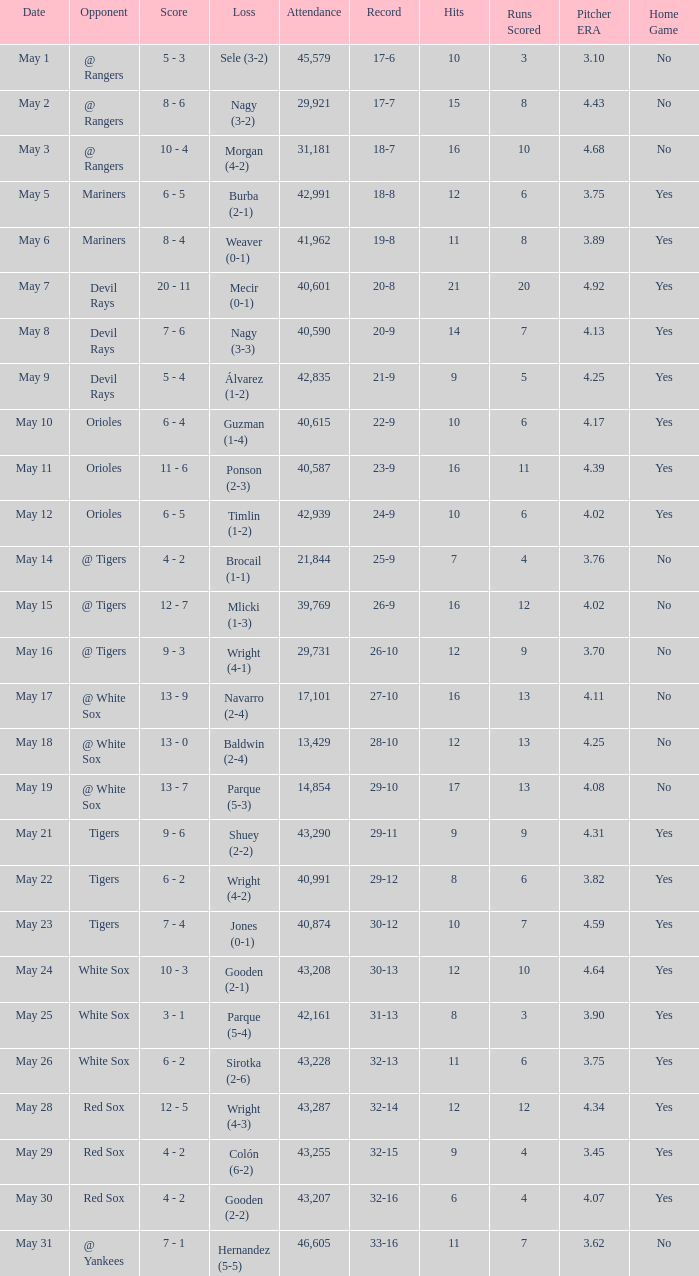What loss has 26-9 as a loss? Mlicki (1-3). 